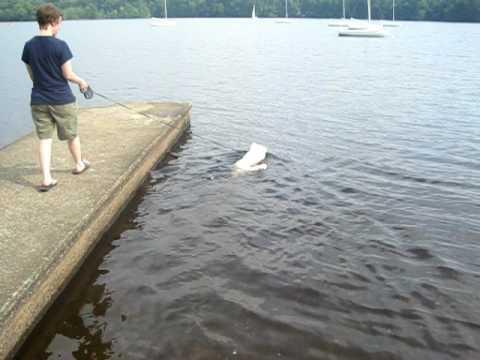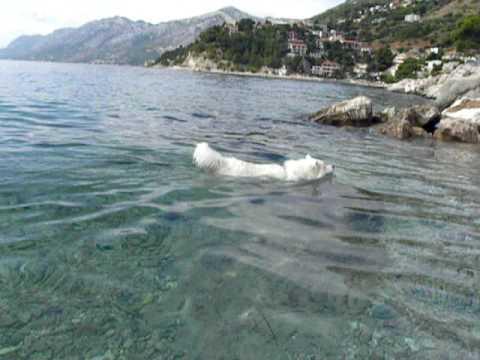The first image is the image on the left, the second image is the image on the right. Analyze the images presented: Is the assertion "There is a human with a white dog surrounded by water in the left image." valid? Answer yes or no. Yes. The first image is the image on the left, the second image is the image on the right. For the images shown, is this caption "There is at least one person visible" true? Answer yes or no. Yes. 